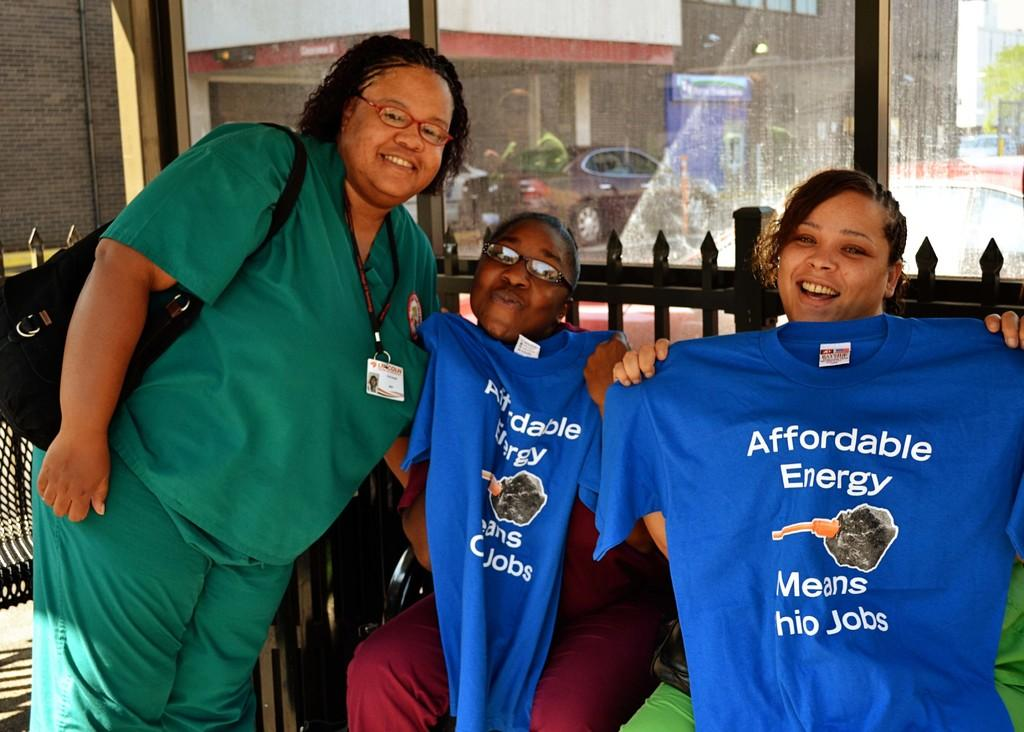<image>
Share a concise interpretation of the image provided. People showing support by holding up shirts that say affordable energy means Ohio jobs. 